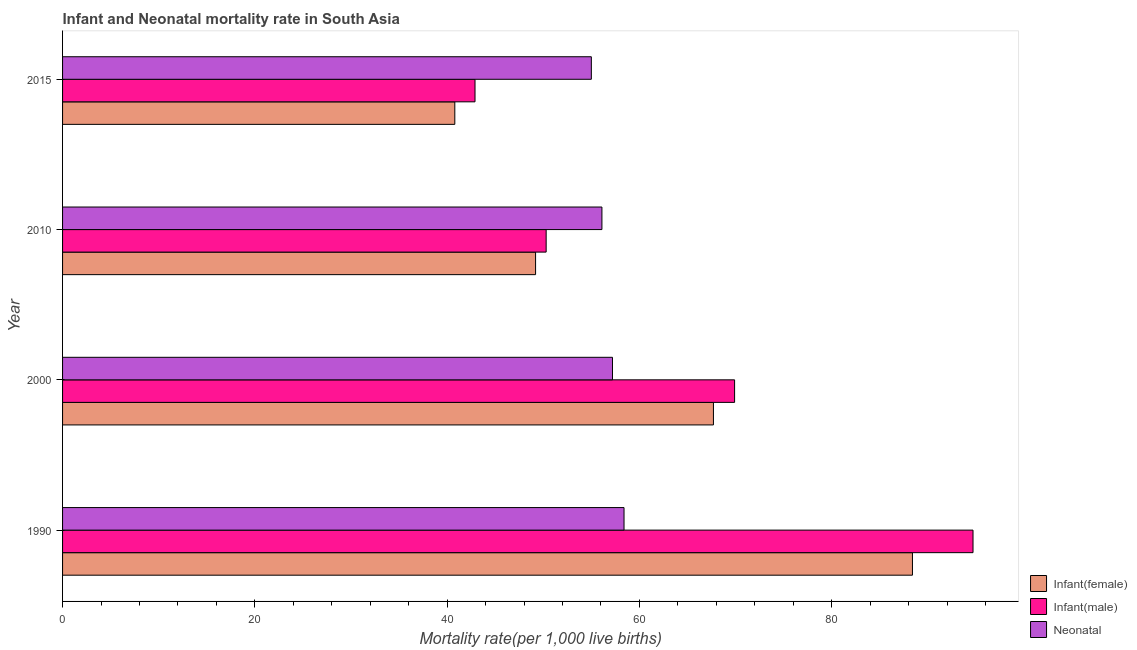How many different coloured bars are there?
Give a very brief answer. 3. Are the number of bars on each tick of the Y-axis equal?
Offer a very short reply. Yes. How many bars are there on the 4th tick from the bottom?
Your response must be concise. 3. What is the label of the 2nd group of bars from the top?
Offer a very short reply. 2010. In how many cases, is the number of bars for a given year not equal to the number of legend labels?
Keep it short and to the point. 0. What is the infant mortality rate(male) in 2010?
Provide a succinct answer. 50.3. Across all years, what is the maximum neonatal mortality rate?
Keep it short and to the point. 58.4. Across all years, what is the minimum infant mortality rate(male)?
Make the answer very short. 42.9. In which year was the neonatal mortality rate maximum?
Your answer should be very brief. 1990. In which year was the infant mortality rate(male) minimum?
Your answer should be compact. 2015. What is the total infant mortality rate(female) in the graph?
Ensure brevity in your answer.  246.1. What is the difference between the infant mortality rate(female) in 1990 and that in 2010?
Your answer should be very brief. 39.2. What is the difference between the neonatal mortality rate in 1990 and the infant mortality rate(female) in 2000?
Provide a succinct answer. -9.3. What is the average infant mortality rate(female) per year?
Give a very brief answer. 61.52. In the year 2010, what is the difference between the infant mortality rate(male) and neonatal mortality rate?
Keep it short and to the point. -5.8. In how many years, is the infant mortality rate(male) greater than 56 ?
Your answer should be very brief. 2. What is the ratio of the infant mortality rate(male) in 1990 to that in 2000?
Keep it short and to the point. 1.35. Is the difference between the infant mortality rate(female) in 1990 and 2010 greater than the difference between the neonatal mortality rate in 1990 and 2010?
Your response must be concise. Yes. What is the difference between the highest and the second highest infant mortality rate(female)?
Ensure brevity in your answer.  20.7. What is the difference between the highest and the lowest infant mortality rate(female)?
Provide a succinct answer. 47.6. Is the sum of the neonatal mortality rate in 2000 and 2010 greater than the maximum infant mortality rate(female) across all years?
Offer a terse response. Yes. What does the 3rd bar from the top in 1990 represents?
Your answer should be very brief. Infant(female). What does the 1st bar from the bottom in 2000 represents?
Keep it short and to the point. Infant(female). How many bars are there?
Offer a very short reply. 12. How many years are there in the graph?
Your answer should be compact. 4. What is the difference between two consecutive major ticks on the X-axis?
Give a very brief answer. 20. Does the graph contain any zero values?
Provide a short and direct response. No. Does the graph contain grids?
Offer a very short reply. No. What is the title of the graph?
Offer a terse response. Infant and Neonatal mortality rate in South Asia. Does "Machinery" appear as one of the legend labels in the graph?
Your answer should be very brief. No. What is the label or title of the X-axis?
Offer a very short reply. Mortality rate(per 1,0 live births). What is the Mortality rate(per 1,000 live births) of Infant(female) in 1990?
Provide a succinct answer. 88.4. What is the Mortality rate(per 1,000 live births) in Infant(male) in 1990?
Offer a terse response. 94.7. What is the Mortality rate(per 1,000 live births) in Neonatal  in 1990?
Provide a short and direct response. 58.4. What is the Mortality rate(per 1,000 live births) of Infant(female) in 2000?
Give a very brief answer. 67.7. What is the Mortality rate(per 1,000 live births) in Infant(male) in 2000?
Keep it short and to the point. 69.9. What is the Mortality rate(per 1,000 live births) in Neonatal  in 2000?
Your answer should be very brief. 57.2. What is the Mortality rate(per 1,000 live births) of Infant(female) in 2010?
Provide a short and direct response. 49.2. What is the Mortality rate(per 1,000 live births) of Infant(male) in 2010?
Ensure brevity in your answer.  50.3. What is the Mortality rate(per 1,000 live births) in Neonatal  in 2010?
Give a very brief answer. 56.1. What is the Mortality rate(per 1,000 live births) of Infant(female) in 2015?
Give a very brief answer. 40.8. What is the Mortality rate(per 1,000 live births) of Infant(male) in 2015?
Provide a succinct answer. 42.9. What is the Mortality rate(per 1,000 live births) of Neonatal  in 2015?
Your response must be concise. 55. Across all years, what is the maximum Mortality rate(per 1,000 live births) of Infant(female)?
Your answer should be compact. 88.4. Across all years, what is the maximum Mortality rate(per 1,000 live births) in Infant(male)?
Offer a very short reply. 94.7. Across all years, what is the maximum Mortality rate(per 1,000 live births) of Neonatal ?
Your answer should be compact. 58.4. Across all years, what is the minimum Mortality rate(per 1,000 live births) in Infant(female)?
Offer a very short reply. 40.8. Across all years, what is the minimum Mortality rate(per 1,000 live births) in Infant(male)?
Offer a terse response. 42.9. What is the total Mortality rate(per 1,000 live births) in Infant(female) in the graph?
Give a very brief answer. 246.1. What is the total Mortality rate(per 1,000 live births) in Infant(male) in the graph?
Offer a terse response. 257.8. What is the total Mortality rate(per 1,000 live births) in Neonatal  in the graph?
Your answer should be very brief. 226.7. What is the difference between the Mortality rate(per 1,000 live births) in Infant(female) in 1990 and that in 2000?
Make the answer very short. 20.7. What is the difference between the Mortality rate(per 1,000 live births) of Infant(male) in 1990 and that in 2000?
Provide a succinct answer. 24.8. What is the difference between the Mortality rate(per 1,000 live births) of Infant(female) in 1990 and that in 2010?
Offer a terse response. 39.2. What is the difference between the Mortality rate(per 1,000 live births) of Infant(male) in 1990 and that in 2010?
Ensure brevity in your answer.  44.4. What is the difference between the Mortality rate(per 1,000 live births) of Neonatal  in 1990 and that in 2010?
Ensure brevity in your answer.  2.3. What is the difference between the Mortality rate(per 1,000 live births) of Infant(female) in 1990 and that in 2015?
Keep it short and to the point. 47.6. What is the difference between the Mortality rate(per 1,000 live births) in Infant(male) in 1990 and that in 2015?
Offer a terse response. 51.8. What is the difference between the Mortality rate(per 1,000 live births) of Infant(male) in 2000 and that in 2010?
Offer a terse response. 19.6. What is the difference between the Mortality rate(per 1,000 live births) of Neonatal  in 2000 and that in 2010?
Your answer should be compact. 1.1. What is the difference between the Mortality rate(per 1,000 live births) in Infant(female) in 2000 and that in 2015?
Keep it short and to the point. 26.9. What is the difference between the Mortality rate(per 1,000 live births) in Neonatal  in 2000 and that in 2015?
Provide a short and direct response. 2.2. What is the difference between the Mortality rate(per 1,000 live births) in Infant(female) in 2010 and that in 2015?
Your response must be concise. 8.4. What is the difference between the Mortality rate(per 1,000 live births) of Infant(male) in 2010 and that in 2015?
Keep it short and to the point. 7.4. What is the difference between the Mortality rate(per 1,000 live births) in Infant(female) in 1990 and the Mortality rate(per 1,000 live births) in Infant(male) in 2000?
Give a very brief answer. 18.5. What is the difference between the Mortality rate(per 1,000 live births) in Infant(female) in 1990 and the Mortality rate(per 1,000 live births) in Neonatal  in 2000?
Offer a very short reply. 31.2. What is the difference between the Mortality rate(per 1,000 live births) in Infant(male) in 1990 and the Mortality rate(per 1,000 live births) in Neonatal  in 2000?
Provide a succinct answer. 37.5. What is the difference between the Mortality rate(per 1,000 live births) in Infant(female) in 1990 and the Mortality rate(per 1,000 live births) in Infant(male) in 2010?
Ensure brevity in your answer.  38.1. What is the difference between the Mortality rate(per 1,000 live births) of Infant(female) in 1990 and the Mortality rate(per 1,000 live births) of Neonatal  in 2010?
Give a very brief answer. 32.3. What is the difference between the Mortality rate(per 1,000 live births) of Infant(male) in 1990 and the Mortality rate(per 1,000 live births) of Neonatal  in 2010?
Provide a succinct answer. 38.6. What is the difference between the Mortality rate(per 1,000 live births) in Infant(female) in 1990 and the Mortality rate(per 1,000 live births) in Infant(male) in 2015?
Ensure brevity in your answer.  45.5. What is the difference between the Mortality rate(per 1,000 live births) in Infant(female) in 1990 and the Mortality rate(per 1,000 live births) in Neonatal  in 2015?
Your response must be concise. 33.4. What is the difference between the Mortality rate(per 1,000 live births) in Infant(male) in 1990 and the Mortality rate(per 1,000 live births) in Neonatal  in 2015?
Your response must be concise. 39.7. What is the difference between the Mortality rate(per 1,000 live births) of Infant(female) in 2000 and the Mortality rate(per 1,000 live births) of Infant(male) in 2010?
Keep it short and to the point. 17.4. What is the difference between the Mortality rate(per 1,000 live births) in Infant(female) in 2000 and the Mortality rate(per 1,000 live births) in Neonatal  in 2010?
Make the answer very short. 11.6. What is the difference between the Mortality rate(per 1,000 live births) in Infant(male) in 2000 and the Mortality rate(per 1,000 live births) in Neonatal  in 2010?
Your answer should be very brief. 13.8. What is the difference between the Mortality rate(per 1,000 live births) of Infant(female) in 2000 and the Mortality rate(per 1,000 live births) of Infant(male) in 2015?
Ensure brevity in your answer.  24.8. What is the difference between the Mortality rate(per 1,000 live births) in Infant(female) in 2000 and the Mortality rate(per 1,000 live births) in Neonatal  in 2015?
Offer a terse response. 12.7. What is the average Mortality rate(per 1,000 live births) in Infant(female) per year?
Offer a very short reply. 61.52. What is the average Mortality rate(per 1,000 live births) in Infant(male) per year?
Your answer should be compact. 64.45. What is the average Mortality rate(per 1,000 live births) in Neonatal  per year?
Your answer should be compact. 56.67. In the year 1990, what is the difference between the Mortality rate(per 1,000 live births) of Infant(female) and Mortality rate(per 1,000 live births) of Neonatal ?
Make the answer very short. 30. In the year 1990, what is the difference between the Mortality rate(per 1,000 live births) in Infant(male) and Mortality rate(per 1,000 live births) in Neonatal ?
Your answer should be very brief. 36.3. In the year 2000, what is the difference between the Mortality rate(per 1,000 live births) of Infant(female) and Mortality rate(per 1,000 live births) of Infant(male)?
Keep it short and to the point. -2.2. In the year 2010, what is the difference between the Mortality rate(per 1,000 live births) of Infant(female) and Mortality rate(per 1,000 live births) of Infant(male)?
Offer a terse response. -1.1. In the year 2010, what is the difference between the Mortality rate(per 1,000 live births) in Infant(male) and Mortality rate(per 1,000 live births) in Neonatal ?
Your answer should be very brief. -5.8. In the year 2015, what is the difference between the Mortality rate(per 1,000 live births) in Infant(female) and Mortality rate(per 1,000 live births) in Neonatal ?
Offer a very short reply. -14.2. In the year 2015, what is the difference between the Mortality rate(per 1,000 live births) of Infant(male) and Mortality rate(per 1,000 live births) of Neonatal ?
Offer a very short reply. -12.1. What is the ratio of the Mortality rate(per 1,000 live births) of Infant(female) in 1990 to that in 2000?
Your response must be concise. 1.31. What is the ratio of the Mortality rate(per 1,000 live births) of Infant(male) in 1990 to that in 2000?
Ensure brevity in your answer.  1.35. What is the ratio of the Mortality rate(per 1,000 live births) of Neonatal  in 1990 to that in 2000?
Offer a very short reply. 1.02. What is the ratio of the Mortality rate(per 1,000 live births) in Infant(female) in 1990 to that in 2010?
Offer a very short reply. 1.8. What is the ratio of the Mortality rate(per 1,000 live births) of Infant(male) in 1990 to that in 2010?
Your response must be concise. 1.88. What is the ratio of the Mortality rate(per 1,000 live births) in Neonatal  in 1990 to that in 2010?
Keep it short and to the point. 1.04. What is the ratio of the Mortality rate(per 1,000 live births) of Infant(female) in 1990 to that in 2015?
Offer a very short reply. 2.17. What is the ratio of the Mortality rate(per 1,000 live births) of Infant(male) in 1990 to that in 2015?
Provide a succinct answer. 2.21. What is the ratio of the Mortality rate(per 1,000 live births) in Neonatal  in 1990 to that in 2015?
Your response must be concise. 1.06. What is the ratio of the Mortality rate(per 1,000 live births) in Infant(female) in 2000 to that in 2010?
Give a very brief answer. 1.38. What is the ratio of the Mortality rate(per 1,000 live births) in Infant(male) in 2000 to that in 2010?
Your answer should be very brief. 1.39. What is the ratio of the Mortality rate(per 1,000 live births) in Neonatal  in 2000 to that in 2010?
Offer a very short reply. 1.02. What is the ratio of the Mortality rate(per 1,000 live births) of Infant(female) in 2000 to that in 2015?
Your response must be concise. 1.66. What is the ratio of the Mortality rate(per 1,000 live births) of Infant(male) in 2000 to that in 2015?
Provide a succinct answer. 1.63. What is the ratio of the Mortality rate(per 1,000 live births) of Infant(female) in 2010 to that in 2015?
Your answer should be compact. 1.21. What is the ratio of the Mortality rate(per 1,000 live births) of Infant(male) in 2010 to that in 2015?
Make the answer very short. 1.17. What is the difference between the highest and the second highest Mortality rate(per 1,000 live births) in Infant(female)?
Your response must be concise. 20.7. What is the difference between the highest and the second highest Mortality rate(per 1,000 live births) in Infant(male)?
Keep it short and to the point. 24.8. What is the difference between the highest and the lowest Mortality rate(per 1,000 live births) of Infant(female)?
Your answer should be compact. 47.6. What is the difference between the highest and the lowest Mortality rate(per 1,000 live births) in Infant(male)?
Your answer should be compact. 51.8. 